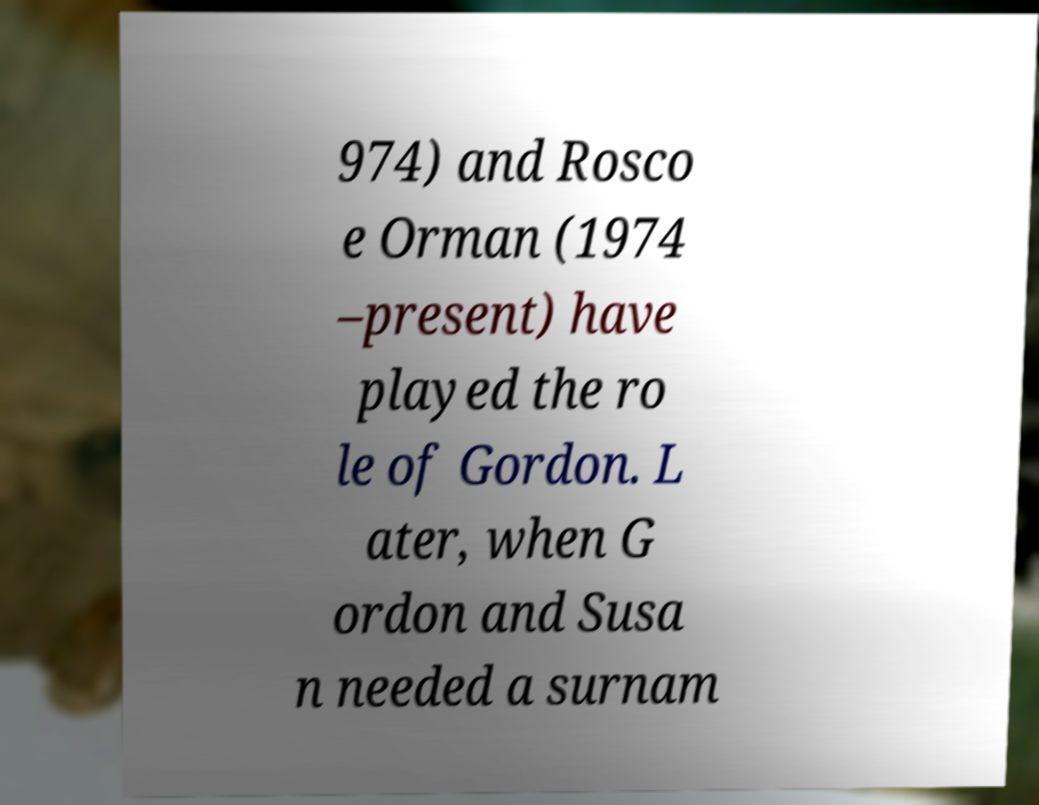Please identify and transcribe the text found in this image. 974) and Rosco e Orman (1974 –present) have played the ro le of Gordon. L ater, when G ordon and Susa n needed a surnam 